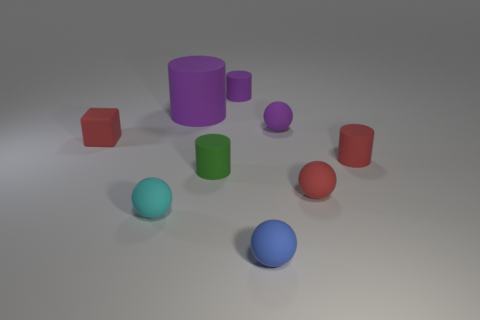How many small things are either blue matte things or purple rubber balls?
Your answer should be very brief. 2. How many tiny things are to the left of the small green matte thing?
Keep it short and to the point. 2. Is there a matte thing of the same color as the cube?
Keep it short and to the point. Yes. What is the shape of the blue thing that is the same size as the block?
Offer a terse response. Sphere. What number of yellow objects are either small matte balls or tiny blocks?
Give a very brief answer. 0. How many cyan rubber spheres have the same size as the red rubber cylinder?
Provide a succinct answer. 1. What number of objects are either small gray matte cylinders or purple objects to the left of the blue object?
Offer a terse response. 2. There is a sphere on the left side of the tiny blue rubber object; is it the same size as the matte cylinder right of the small blue thing?
Ensure brevity in your answer.  Yes. What number of other small blue things have the same shape as the blue rubber thing?
Provide a short and direct response. 0. There is a big purple thing that is made of the same material as the purple ball; what shape is it?
Give a very brief answer. Cylinder. 